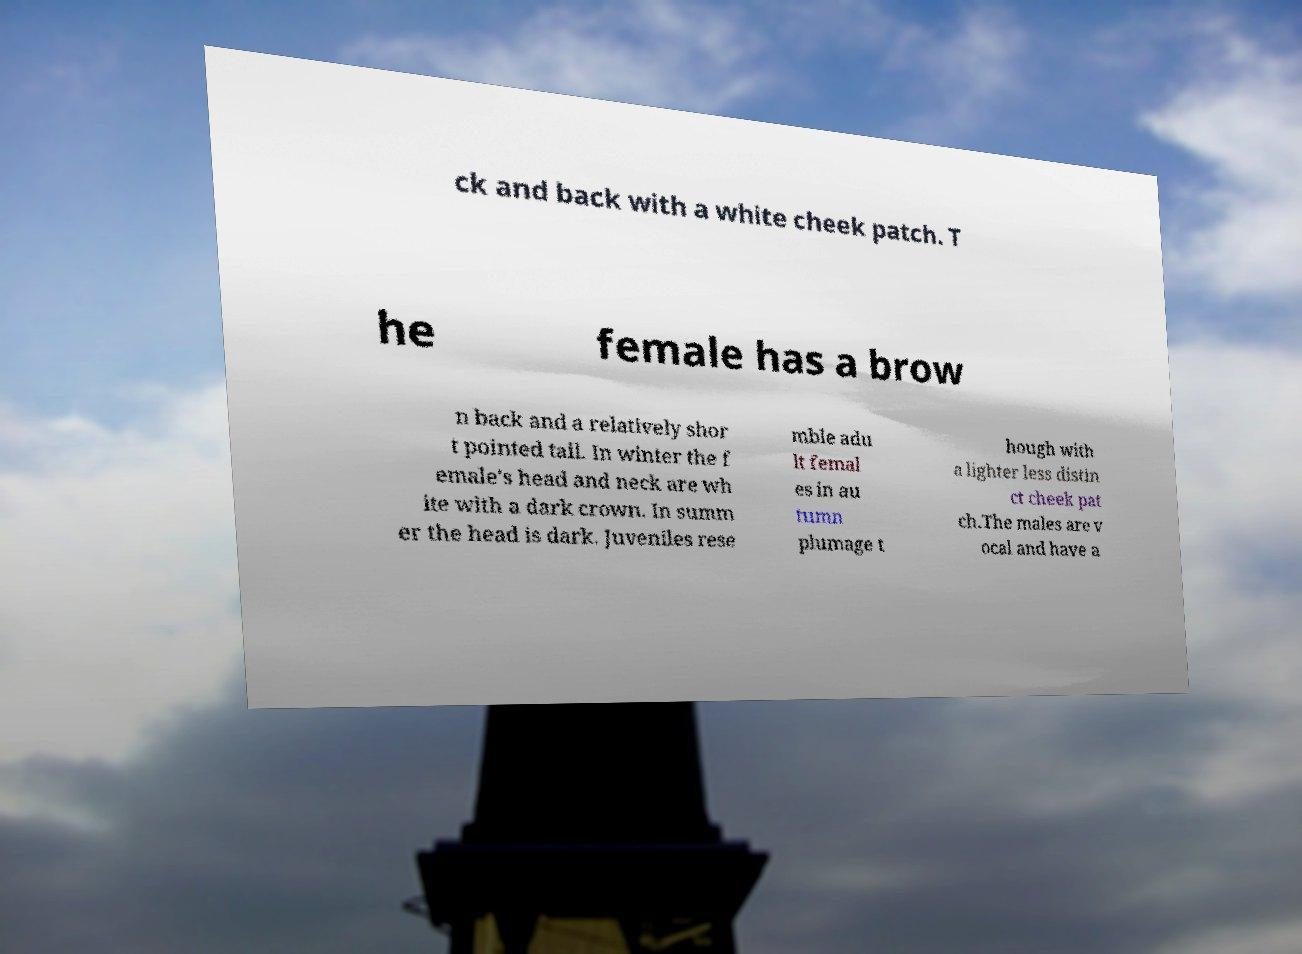Could you extract and type out the text from this image? ck and back with a white cheek patch. T he female has a brow n back and a relatively shor t pointed tail. In winter the f emale's head and neck are wh ite with a dark crown. In summ er the head is dark. Juveniles rese mble adu lt femal es in au tumn plumage t hough with a lighter less distin ct cheek pat ch.The males are v ocal and have a 